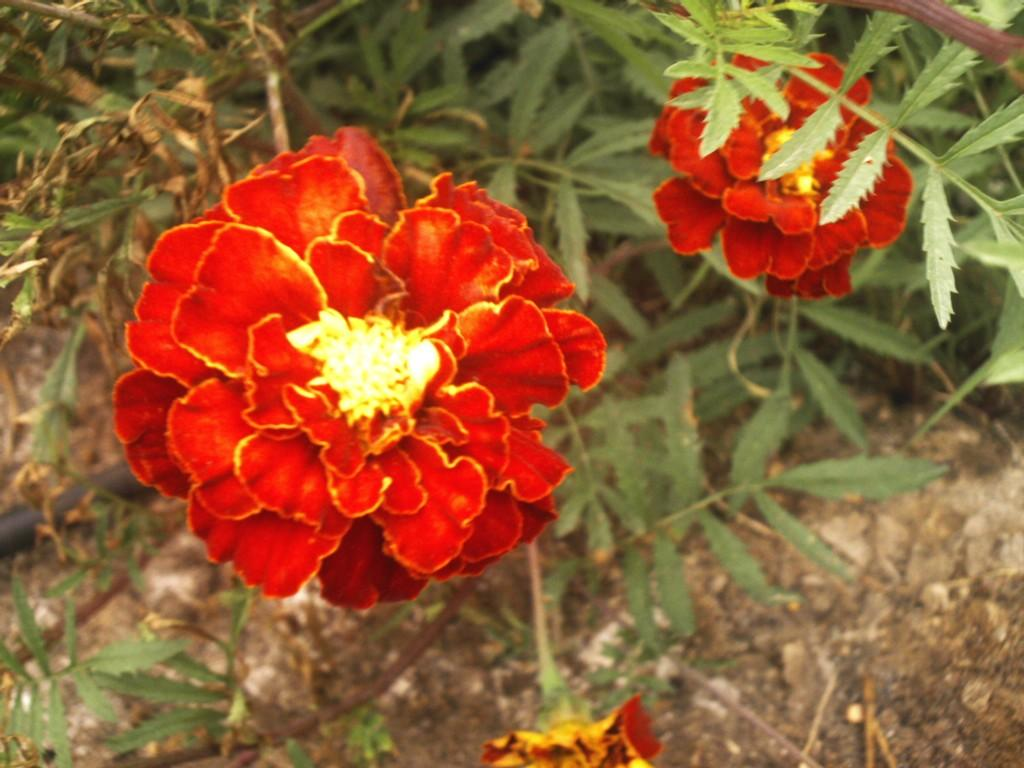How many flowers are in the image? There are three flowers in the image. What color are the petals of the flowers? The flowers have red petals. What can be seen in the background of the image? There are plants in the background of the image. What type of surface is visible in the image? There is soil visible in the image. What type of material is present on the floor in the image? There are stones on the floor in the image. What type of bottle is being used to water the flowers in the image? There is no bottle present in the image; it only shows the flowers, plants, soil, and stones. How many lizards can be seen crawling on the flowers in the image? There are no lizards present in the image; it only shows the flowers, plants, soil, and stones. 